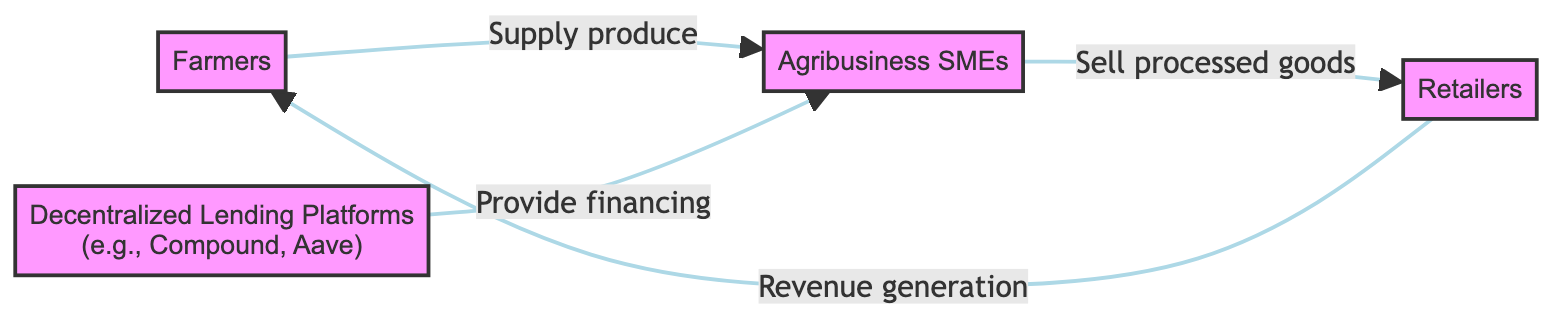What are the main nodes in the diagram? The main nodes in the diagram are Farmers, Decentralized Lending Platforms, Agribusiness SMEs, and Retailers. Each represents a key participant in the financing flow related to SMEs in the agricultural sector.
Answer: Farmers, Decentralized Lending Platforms, Agribusiness SMEs, Retailers Who provides financing to the SMEs? The Decentralized Lending Platforms provide financing to the Agribusiness SMEs as indicated by the directed edge connecting these two nodes in the diagram.
Answer: Decentralized Lending Platforms What do Agribusiness SMEs sell to the Retailers? Agribusiness SMEs sell processed goods to Retailers, as shown by the arrow directed from SME agribusiness to Retailer.
Answer: Processed goods How many edges are in the diagram? There are four edges in the diagram, each representing a flow of interaction or transaction between the nodes present in the food chain.
Answer: Four What is the relationship between Farmers and Retailers? Farmers supply produce to Agribusiness SMEs, and Retailers generate revenue from them; this indicates an indirect relationship where Retailers benefit from the produce supplied by Farmers.
Answer: Indirect relationship What type of platforms are mentioned in the diagram? The diagram mentions Decentralized Lending Platforms, specifically examples like Compound and Aave, which are critical in financing the Agribusiness SMEs.
Answer: Decentralized Lending Platforms How do Retailers generate revenue according to the diagram? Retailers generate revenue by selling the processed goods received from Agribusiness SMEs, as illustrated by the direct edge flowing from SMEs to Retailers.
Answer: Selling processed goods What is the flow of funding in the diagram? The flow of funding starts from Decentralized Lending Platforms to Agribusiness SMEs, who then use this funding to process agricultural products and sell them to Retailers. This illustrates how financing supports the agricultural supply chain.
Answer: Funding from Decentralized Lending Platforms to Agribusiness SMEs Which node is directly connected to both Farmers and Retailers? The Agribusiness SMEs node is directly connected to both Farmers (who supply produce) and Retailers (who purchase processed goods), highlighting its central role in the diagram.
Answer: Agribusiness SMEs 